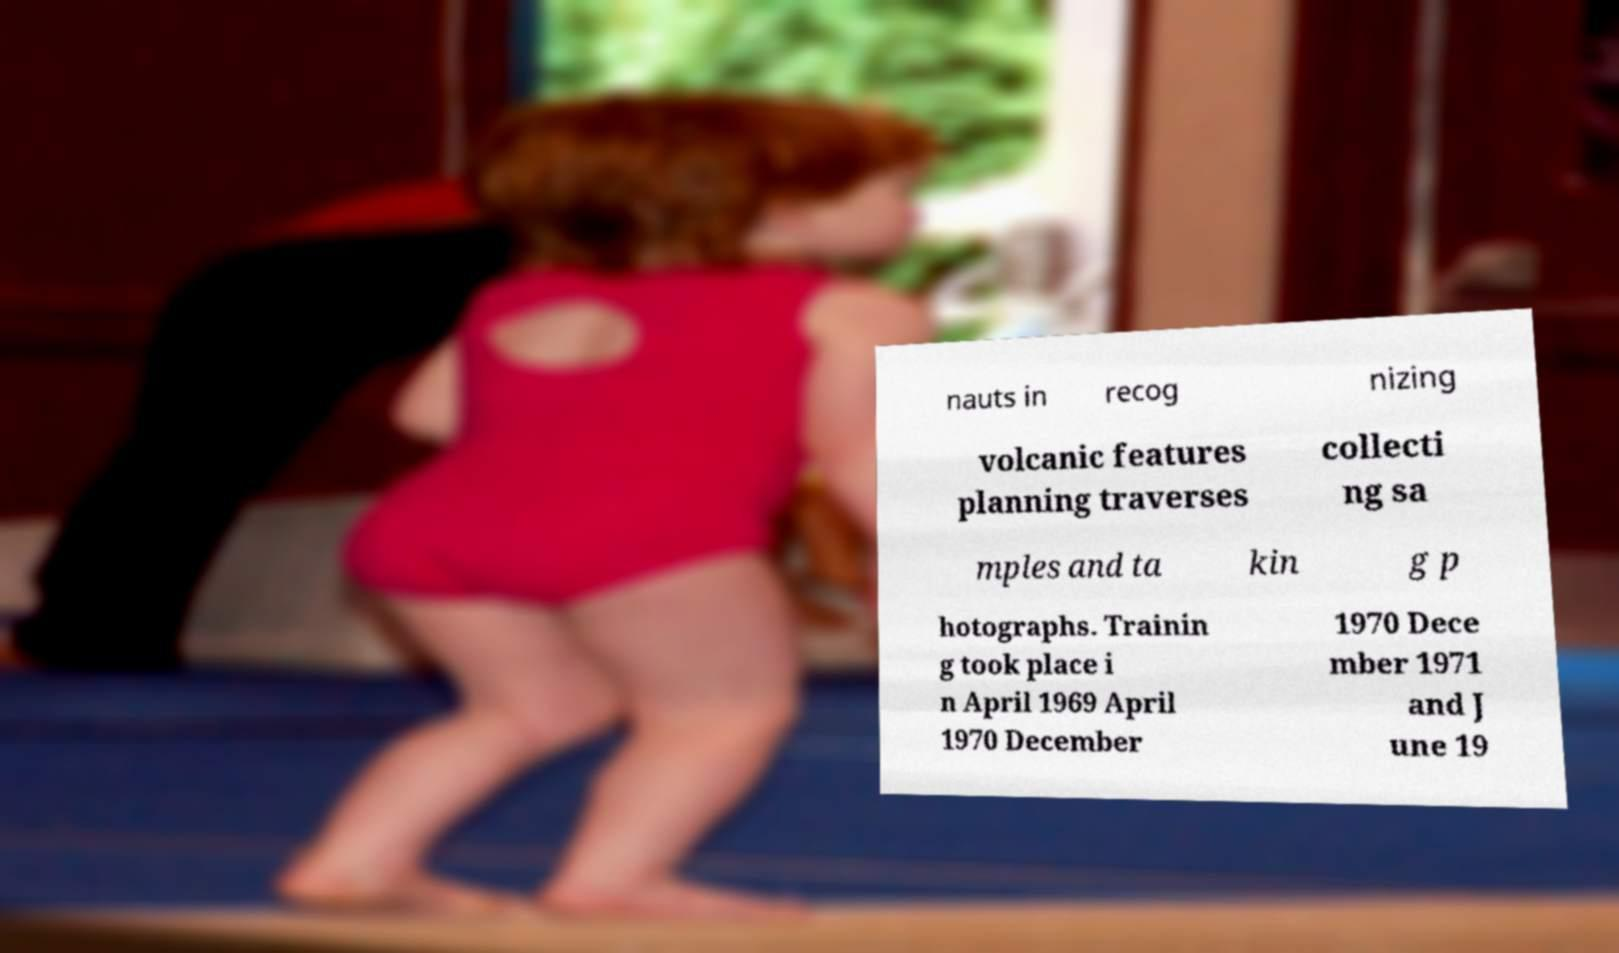For documentation purposes, I need the text within this image transcribed. Could you provide that? nauts in recog nizing volcanic features planning traverses collecti ng sa mples and ta kin g p hotographs. Trainin g took place i n April 1969 April 1970 December 1970 Dece mber 1971 and J une 19 